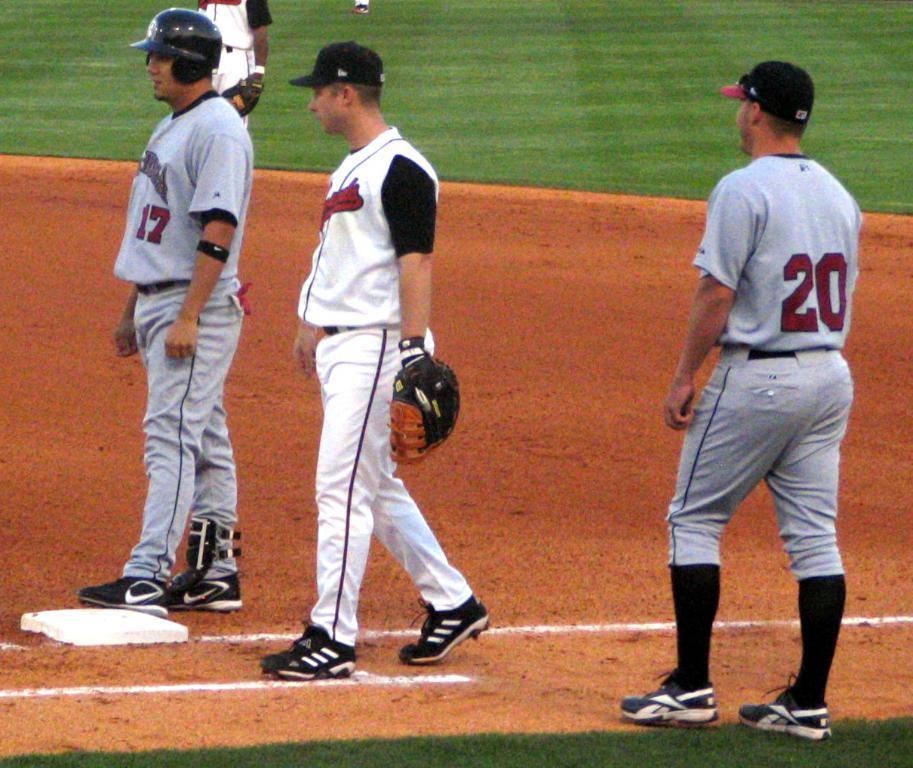What jersey number is the player on the right?
Provide a succinct answer. 20. 